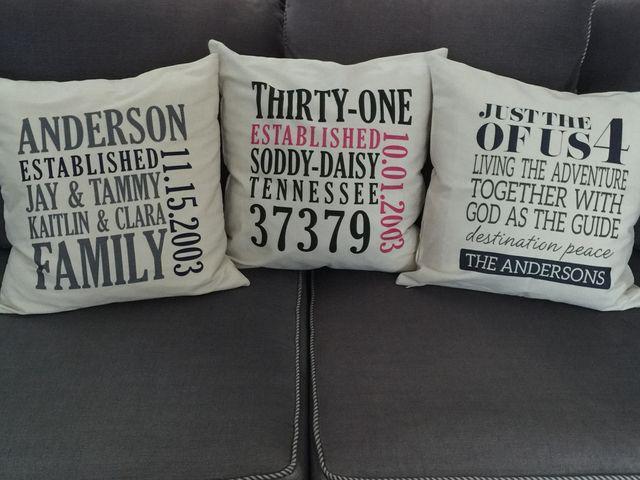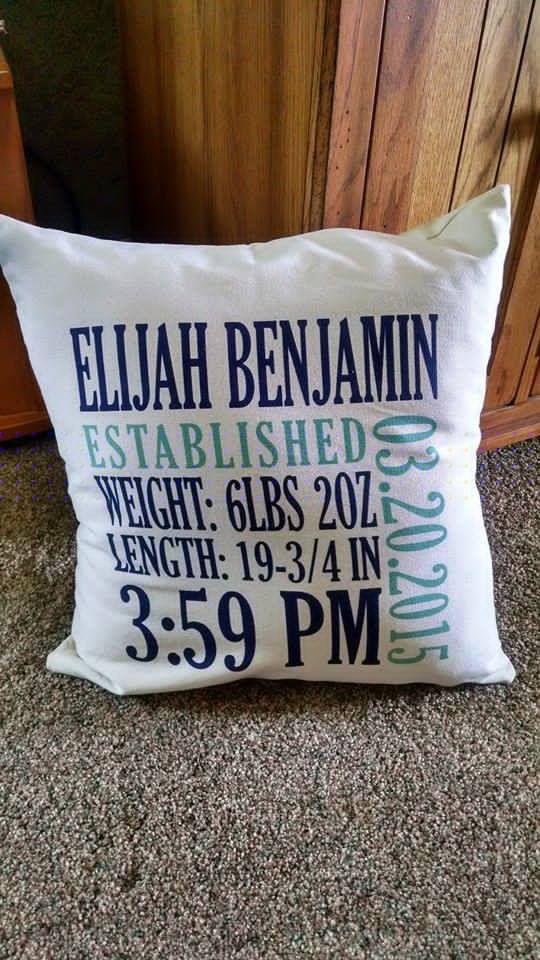The first image is the image on the left, the second image is the image on the right. For the images shown, is this caption "There are an even number of pillows and no people." true? Answer yes or no. Yes. The first image is the image on the left, the second image is the image on the right. For the images displayed, is the sentence "The large squarish item in the foreground of one image is stamped at the center with a single alphabet letter." factually correct? Answer yes or no. No. 